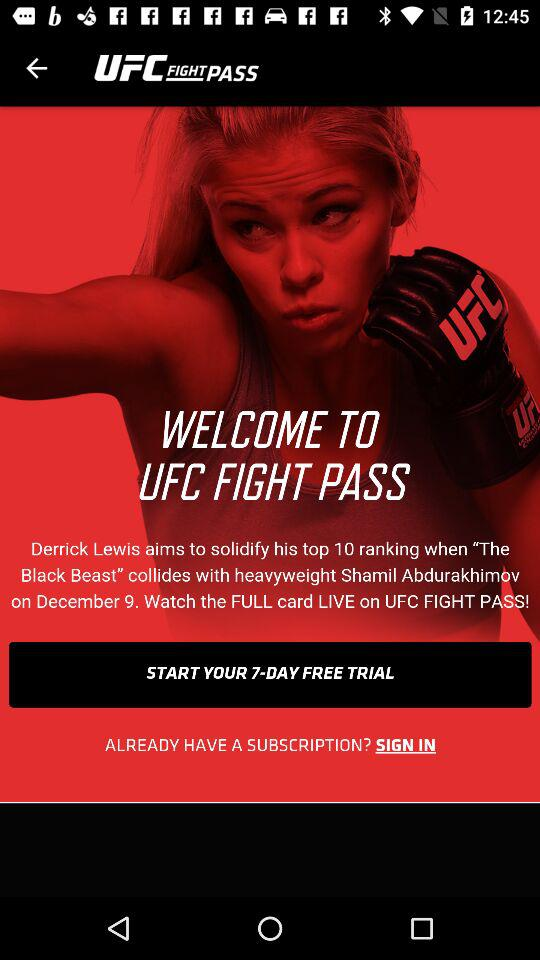For how many days will the free trial last? The free trail will last for 7 days. 